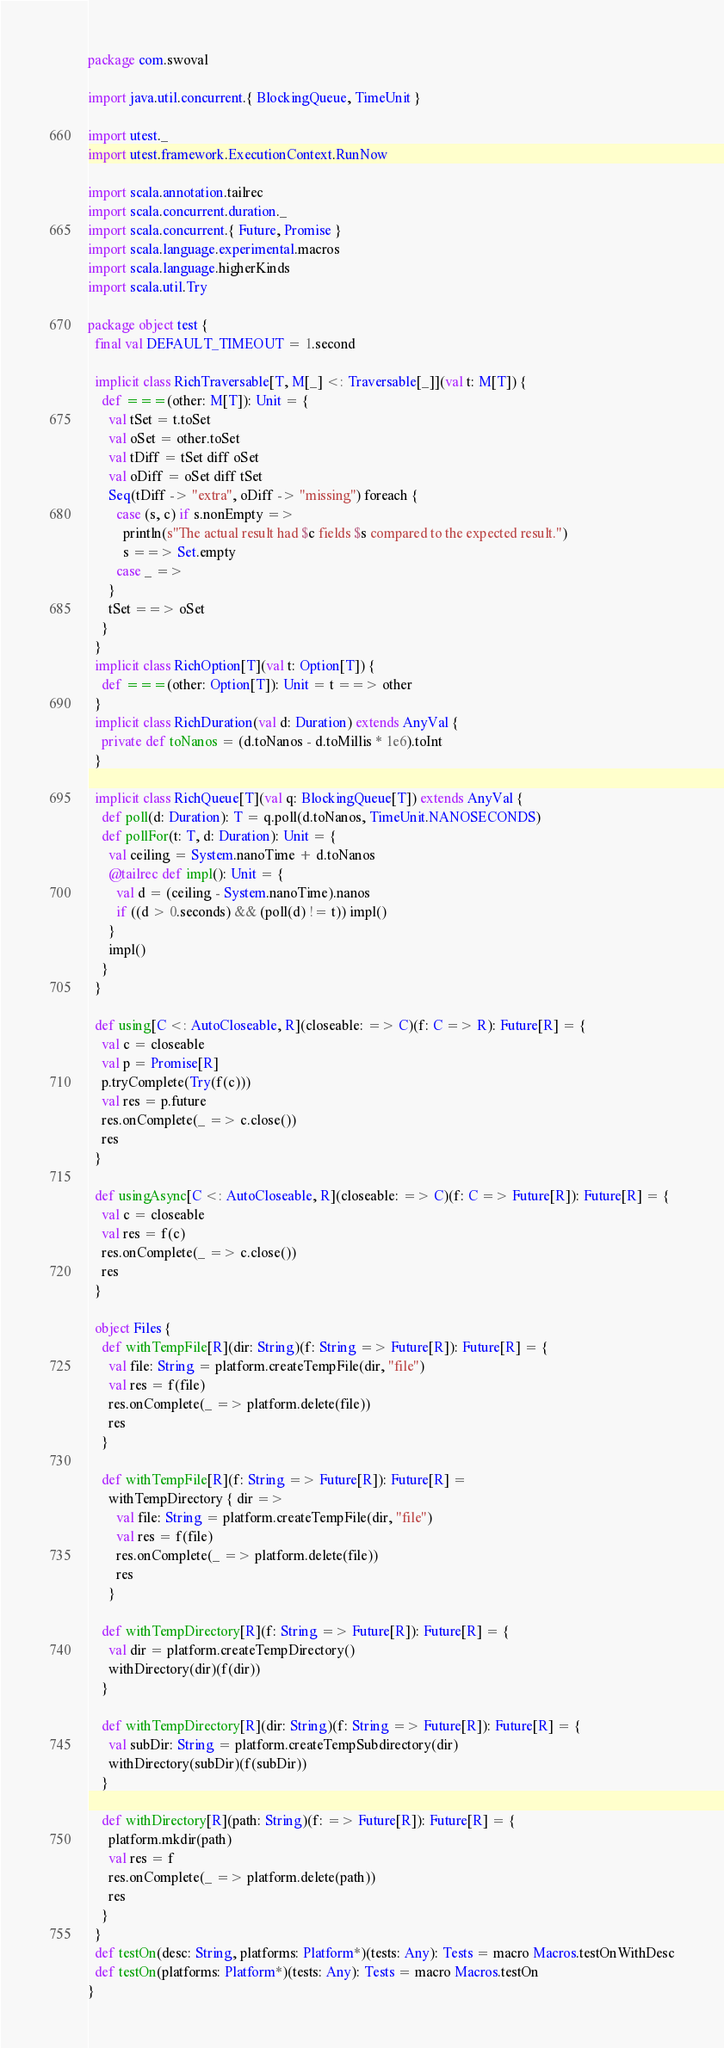<code> <loc_0><loc_0><loc_500><loc_500><_Scala_>package com.swoval

import java.util.concurrent.{ BlockingQueue, TimeUnit }

import utest._
import utest.framework.ExecutionContext.RunNow

import scala.annotation.tailrec
import scala.concurrent.duration._
import scala.concurrent.{ Future, Promise }
import scala.language.experimental.macros
import scala.language.higherKinds
import scala.util.Try

package object test {
  final val DEFAULT_TIMEOUT = 1.second

  implicit class RichTraversable[T, M[_] <: Traversable[_]](val t: M[T]) {
    def ===(other: M[T]): Unit = {
      val tSet = t.toSet
      val oSet = other.toSet
      val tDiff = tSet diff oSet
      val oDiff = oSet diff tSet
      Seq(tDiff -> "extra", oDiff -> "missing") foreach {
        case (s, c) if s.nonEmpty =>
          println(s"The actual result had $c fields $s compared to the expected result.")
          s ==> Set.empty
        case _ =>
      }
      tSet ==> oSet
    }
  }
  implicit class RichOption[T](val t: Option[T]) {
    def ===(other: Option[T]): Unit = t ==> other
  }
  implicit class RichDuration(val d: Duration) extends AnyVal {
    private def toNanos = (d.toNanos - d.toMillis * 1e6).toInt
  }

  implicit class RichQueue[T](val q: BlockingQueue[T]) extends AnyVal {
    def poll(d: Duration): T = q.poll(d.toNanos, TimeUnit.NANOSECONDS)
    def pollFor(t: T, d: Duration): Unit = {
      val ceiling = System.nanoTime + d.toNanos
      @tailrec def impl(): Unit = {
        val d = (ceiling - System.nanoTime).nanos
        if ((d > 0.seconds) && (poll(d) != t)) impl()
      }
      impl()
    }
  }

  def using[C <: AutoCloseable, R](closeable: => C)(f: C => R): Future[R] = {
    val c = closeable
    val p = Promise[R]
    p.tryComplete(Try(f(c)))
    val res = p.future
    res.onComplete(_ => c.close())
    res
  }

  def usingAsync[C <: AutoCloseable, R](closeable: => C)(f: C => Future[R]): Future[R] = {
    val c = closeable
    val res = f(c)
    res.onComplete(_ => c.close())
    res
  }

  object Files {
    def withTempFile[R](dir: String)(f: String => Future[R]): Future[R] = {
      val file: String = platform.createTempFile(dir, "file")
      val res = f(file)
      res.onComplete(_ => platform.delete(file))
      res
    }

    def withTempFile[R](f: String => Future[R]): Future[R] =
      withTempDirectory { dir =>
        val file: String = platform.createTempFile(dir, "file")
        val res = f(file)
        res.onComplete(_ => platform.delete(file))
        res
      }

    def withTempDirectory[R](f: String => Future[R]): Future[R] = {
      val dir = platform.createTempDirectory()
      withDirectory(dir)(f(dir))
    }

    def withTempDirectory[R](dir: String)(f: String => Future[R]): Future[R] = {
      val subDir: String = platform.createTempSubdirectory(dir)
      withDirectory(subDir)(f(subDir))
    }

    def withDirectory[R](path: String)(f: => Future[R]): Future[R] = {
      platform.mkdir(path)
      val res = f
      res.onComplete(_ => platform.delete(path))
      res
    }
  }
  def testOn(desc: String, platforms: Platform*)(tests: Any): Tests = macro Macros.testOnWithDesc
  def testOn(platforms: Platform*)(tests: Any): Tests = macro Macros.testOn
}
</code> 